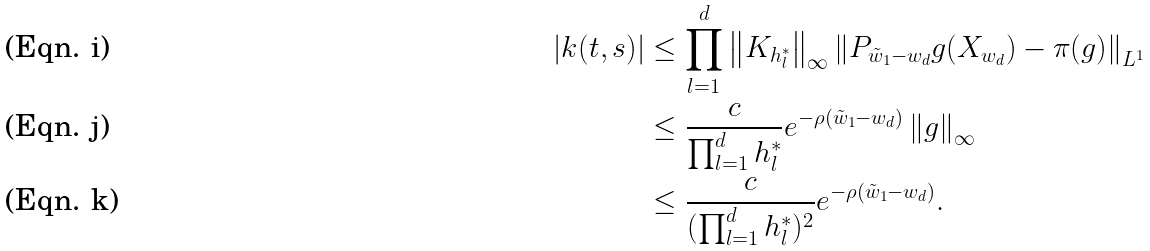<formula> <loc_0><loc_0><loc_500><loc_500>| k ( t , s ) | & \leq \prod _ { l = 1 } ^ { d } \left \| K _ { h _ { l } ^ { * } } \right \| _ { \infty } \left \| P _ { \tilde { w } _ { 1 } - w _ { d } } g ( X _ { w _ { d } } ) - \pi ( g ) \right \| _ { L ^ { 1 } } \\ & \leq \frac { c } { \prod _ { l = 1 } ^ { d } h _ { l } ^ { * } } e ^ { - \rho ( \tilde { w } _ { 1 } - w _ { d } ) } \left \| g \right \| _ { \infty } \\ & \leq \frac { c } { ( \prod _ { l = 1 } ^ { d } h _ { l } ^ { * } ) ^ { 2 } } e ^ { - \rho ( \tilde { w } _ { 1 } - w _ { d } ) } .</formula> 